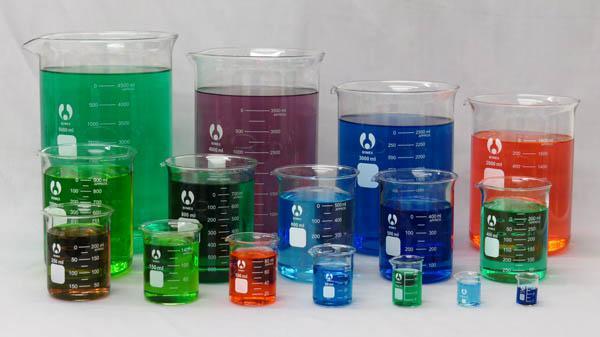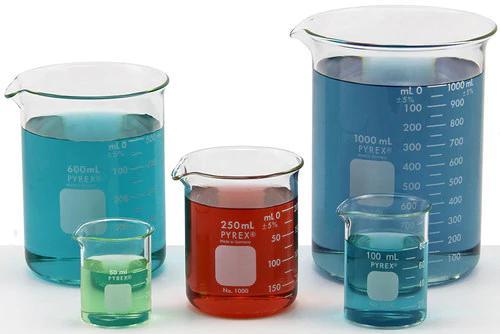The first image is the image on the left, the second image is the image on the right. Analyze the images presented: Is the assertion "There are unfilled beakers." valid? Answer yes or no. No. The first image is the image on the left, the second image is the image on the right. Examine the images to the left and right. Is the description "In at least one image there are five beckers with only two full of blue liquid." accurate? Answer yes or no. No. 